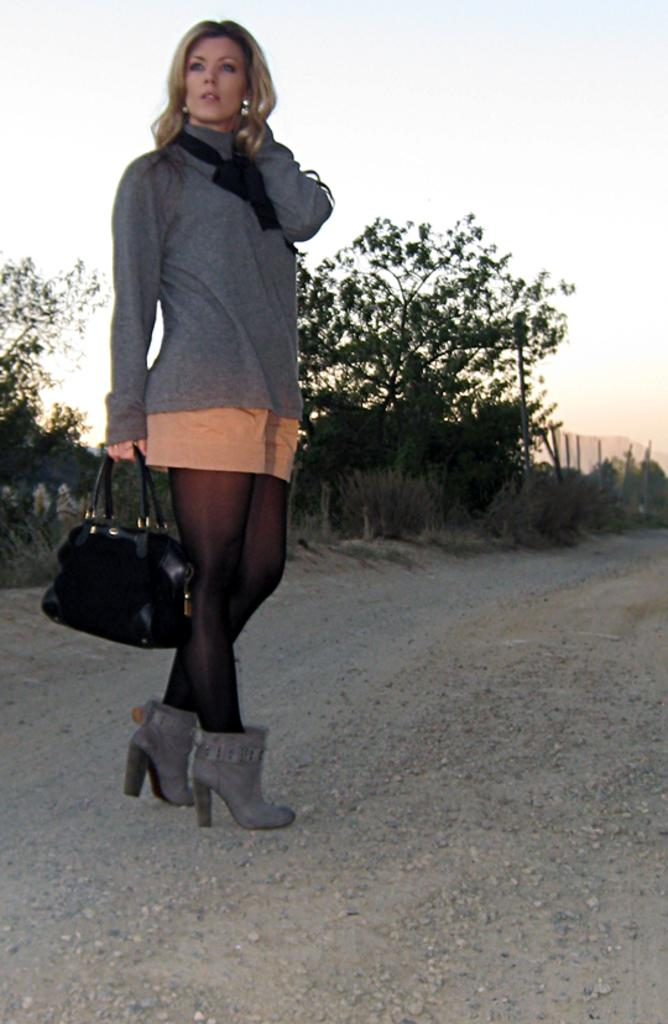Who is present in the image? There is a woman in the image. What is the woman doing in the image? The woman is standing in the image. What is the woman holding in the image? The woman is holding a handbag in the image. What can be seen in the background of the image? There is a road and trees visible in the image. What type of wine is the woman drinking in the image? There is no wine present in the image; the woman is holding a handbag. What does the caption on the image say? There is no caption present in the image. 